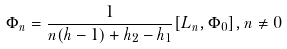<formula> <loc_0><loc_0><loc_500><loc_500>\Phi _ { n } = \frac { 1 } { n ( h - 1 ) + h _ { 2 } - h _ { 1 } } [ L _ { n } , \Phi _ { 0 } ] , n \neq 0</formula> 